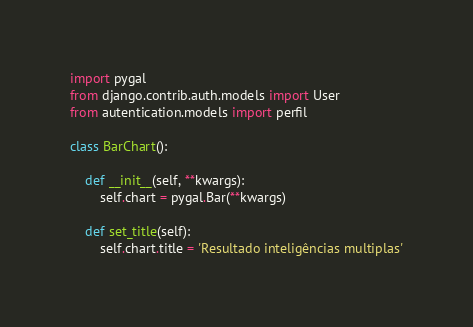<code> <loc_0><loc_0><loc_500><loc_500><_Python_>import pygal
from django.contrib.auth.models import User
from autentication.models import perfil 

class BarChart():

    def __init__(self, **kwargs):
        self.chart = pygal.Bar(**kwargs)
        
    def set_title(self):
        self.chart.title = 'Resultado inteligências multiplas'
</code> 